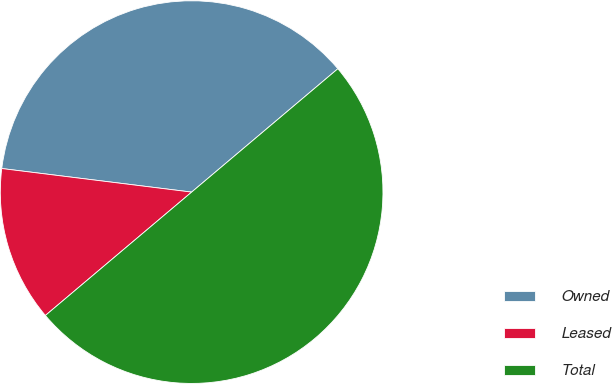Convert chart. <chart><loc_0><loc_0><loc_500><loc_500><pie_chart><fcel>Owned<fcel>Leased<fcel>Total<nl><fcel>36.88%<fcel>13.12%<fcel>50.0%<nl></chart> 